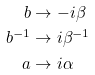<formula> <loc_0><loc_0><loc_500><loc_500>b & \rightarrow - i \beta \\ b ^ { - 1 } & \rightarrow i \beta ^ { - 1 } \\ a & \rightarrow i \alpha</formula> 